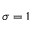Convert formula to latex. <formula><loc_0><loc_0><loc_500><loc_500>\sigma = 1</formula> 